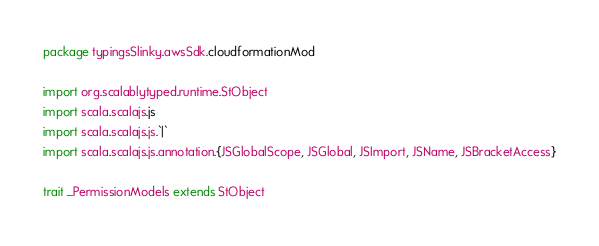Convert code to text. <code><loc_0><loc_0><loc_500><loc_500><_Scala_>package typingsSlinky.awsSdk.cloudformationMod

import org.scalablytyped.runtime.StObject
import scala.scalajs.js
import scala.scalajs.js.`|`
import scala.scalajs.js.annotation.{JSGlobalScope, JSGlobal, JSImport, JSName, JSBracketAccess}

trait _PermissionModels extends StObject
</code> 